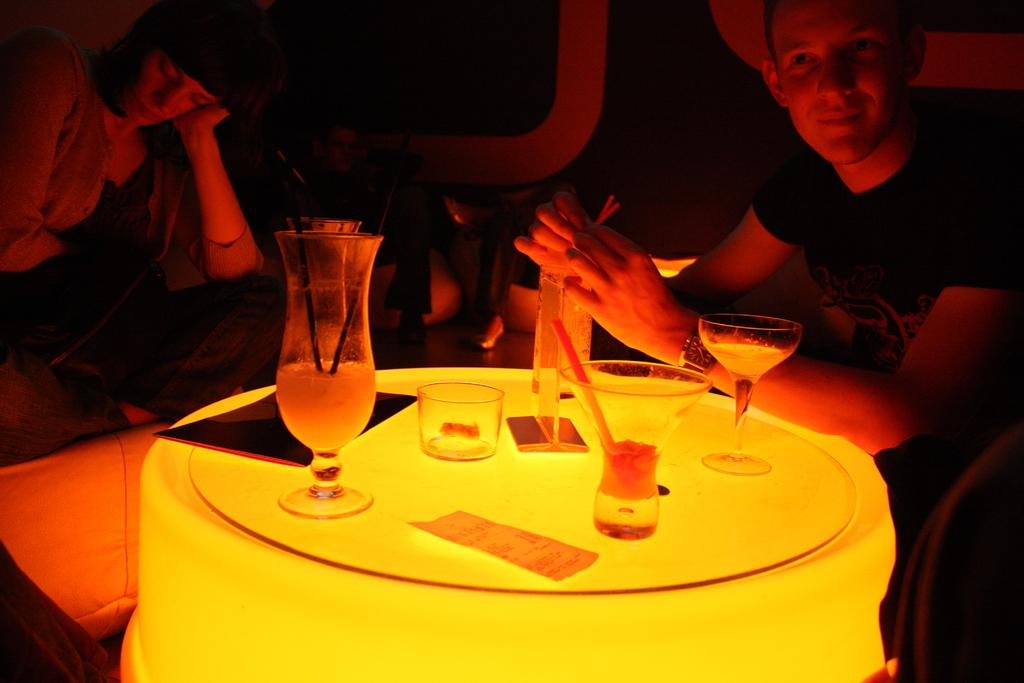Who are the people in the image? There is a woman and a man in the image. What are the woman and the man doing in the image? Both the woman and the man are sitting in front of a table. What objects can be seen on the table? There are glasses on the table. What is the man holding in the image? The man is holding a straw. How many pieces of furniture are visible in the image? There is no furniture visible in the image; only a table and chairs are present. What type of apples are being served on the table? There are no apples present in the image; only glasses can be seen on the table. 